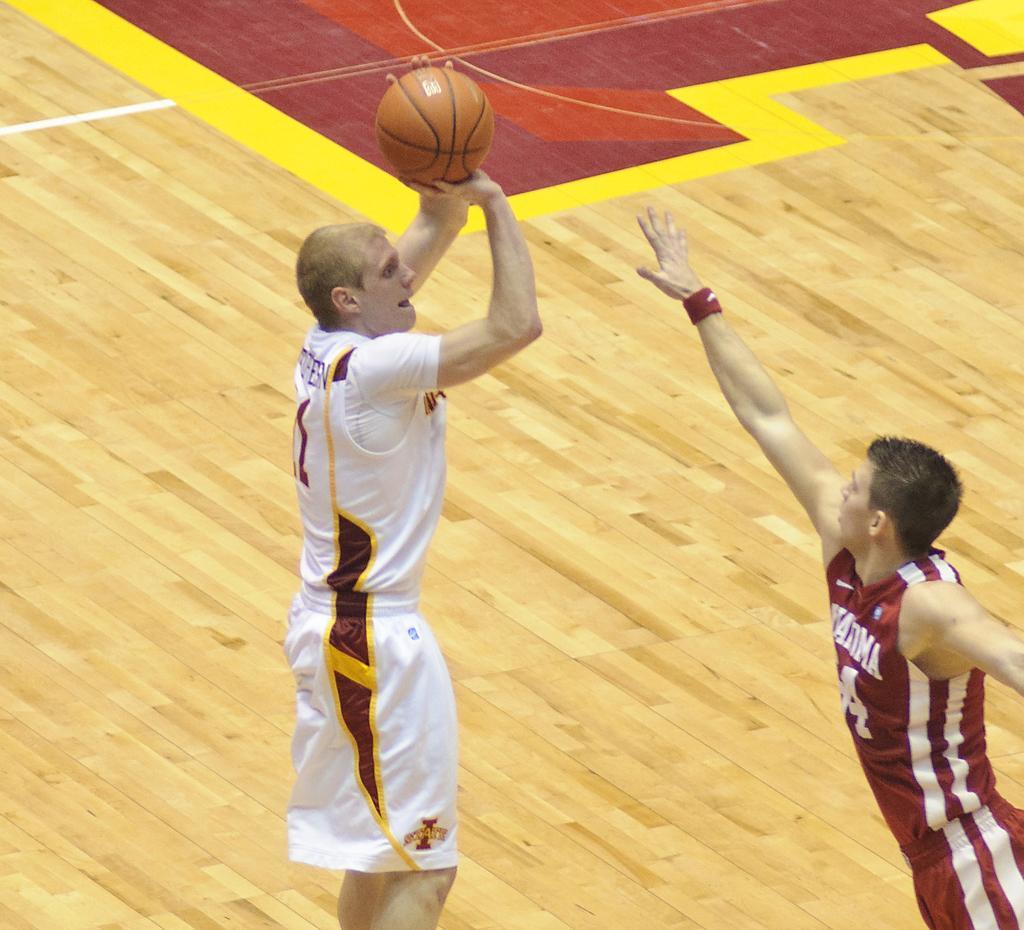Please provide a concise description of this image. On the left side, there is a person in a white color T-shirt, holding a basketball. On the right side, there is a person in a red color T-shirt, stretched his hand. In the background, there is a painting on the floor. 